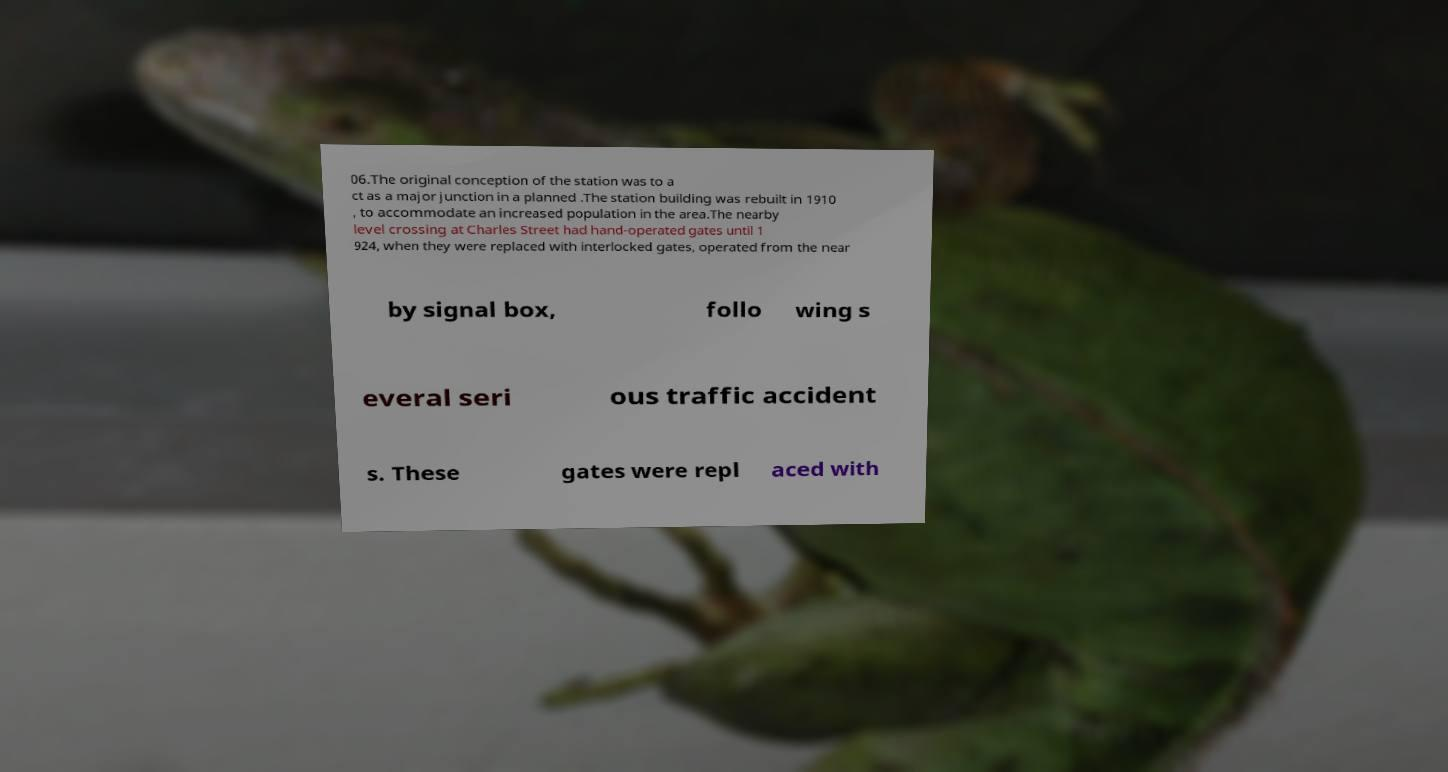Can you read and provide the text displayed in the image?This photo seems to have some interesting text. Can you extract and type it out for me? 06.The original conception of the station was to a ct as a major junction in a planned .The station building was rebuilt in 1910 , to accommodate an increased population in the area.The nearby level crossing at Charles Street had hand-operated gates until 1 924, when they were replaced with interlocked gates, operated from the near by signal box, follo wing s everal seri ous traffic accident s. These gates were repl aced with 